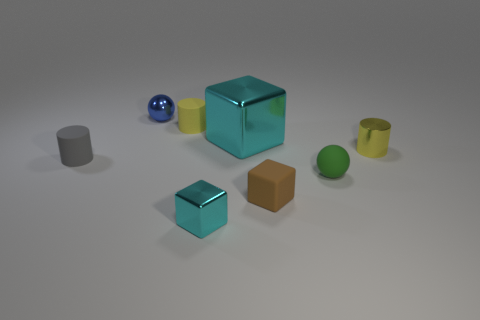There is a rubber cylinder that is left of the blue thing; how big is it?
Your answer should be compact. Small. How many cylinders have the same color as the large thing?
Your answer should be very brief. 0. Are there any small green matte things right of the shiny cylinder that is behind the small brown matte block?
Offer a very short reply. No. There is a tiny metal object behind the yellow metallic thing; is its color the same as the small cylinder that is right of the green rubber object?
Your response must be concise. No. What is the color of the other ball that is the same size as the blue metal sphere?
Make the answer very short. Green. Are there the same number of tiny blue metal balls that are on the left side of the tiny gray cylinder and gray objects that are right of the brown matte block?
Offer a very short reply. Yes. The cylinder that is to the left of the tiny matte cylinder that is behind the tiny gray rubber object is made of what material?
Ensure brevity in your answer.  Rubber. How many things are tiny metal balls or shiny cubes?
Give a very brief answer. 3. There is a object that is the same color as the tiny metallic cylinder; what is its size?
Offer a very short reply. Small. Are there fewer small purple matte things than small shiny cylinders?
Your answer should be compact. Yes. 